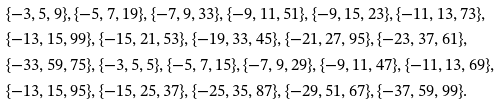<formula> <loc_0><loc_0><loc_500><loc_500>& \{ - 3 , 5 , 9 \} , \{ - 5 , 7 , 1 9 \} , \{ - 7 , 9 , 3 3 \} , \{ - 9 , 1 1 , 5 1 \} , \{ - 9 , 1 5 , 2 3 \} , \{ - 1 1 , 1 3 , 7 3 \} , \\ & \{ - 1 3 , 1 5 , 9 9 \} , \{ - 1 5 , 2 1 , 5 3 \} , \{ - 1 9 , 3 3 , 4 5 \} , \{ - 2 1 , 2 7 , 9 5 \} , \{ - 2 3 , 3 7 , 6 1 \} , \\ & \{ - 3 3 , 5 9 , 7 5 \} , \{ - 3 , 5 , 5 \} , \{ - 5 , 7 , 1 5 \} , \{ - 7 , 9 , 2 9 \} , \{ - 9 , 1 1 , 4 7 \} , \{ - 1 1 , 1 3 , 6 9 \} , \\ & \{ - 1 3 , 1 5 , 9 5 \} , \{ - 1 5 , 2 5 , 3 7 \} , \{ - 2 5 , 3 5 , 8 7 \} , \{ - 2 9 , 5 1 , 6 7 \} , \{ - 3 7 , 5 9 , 9 9 \} .</formula> 